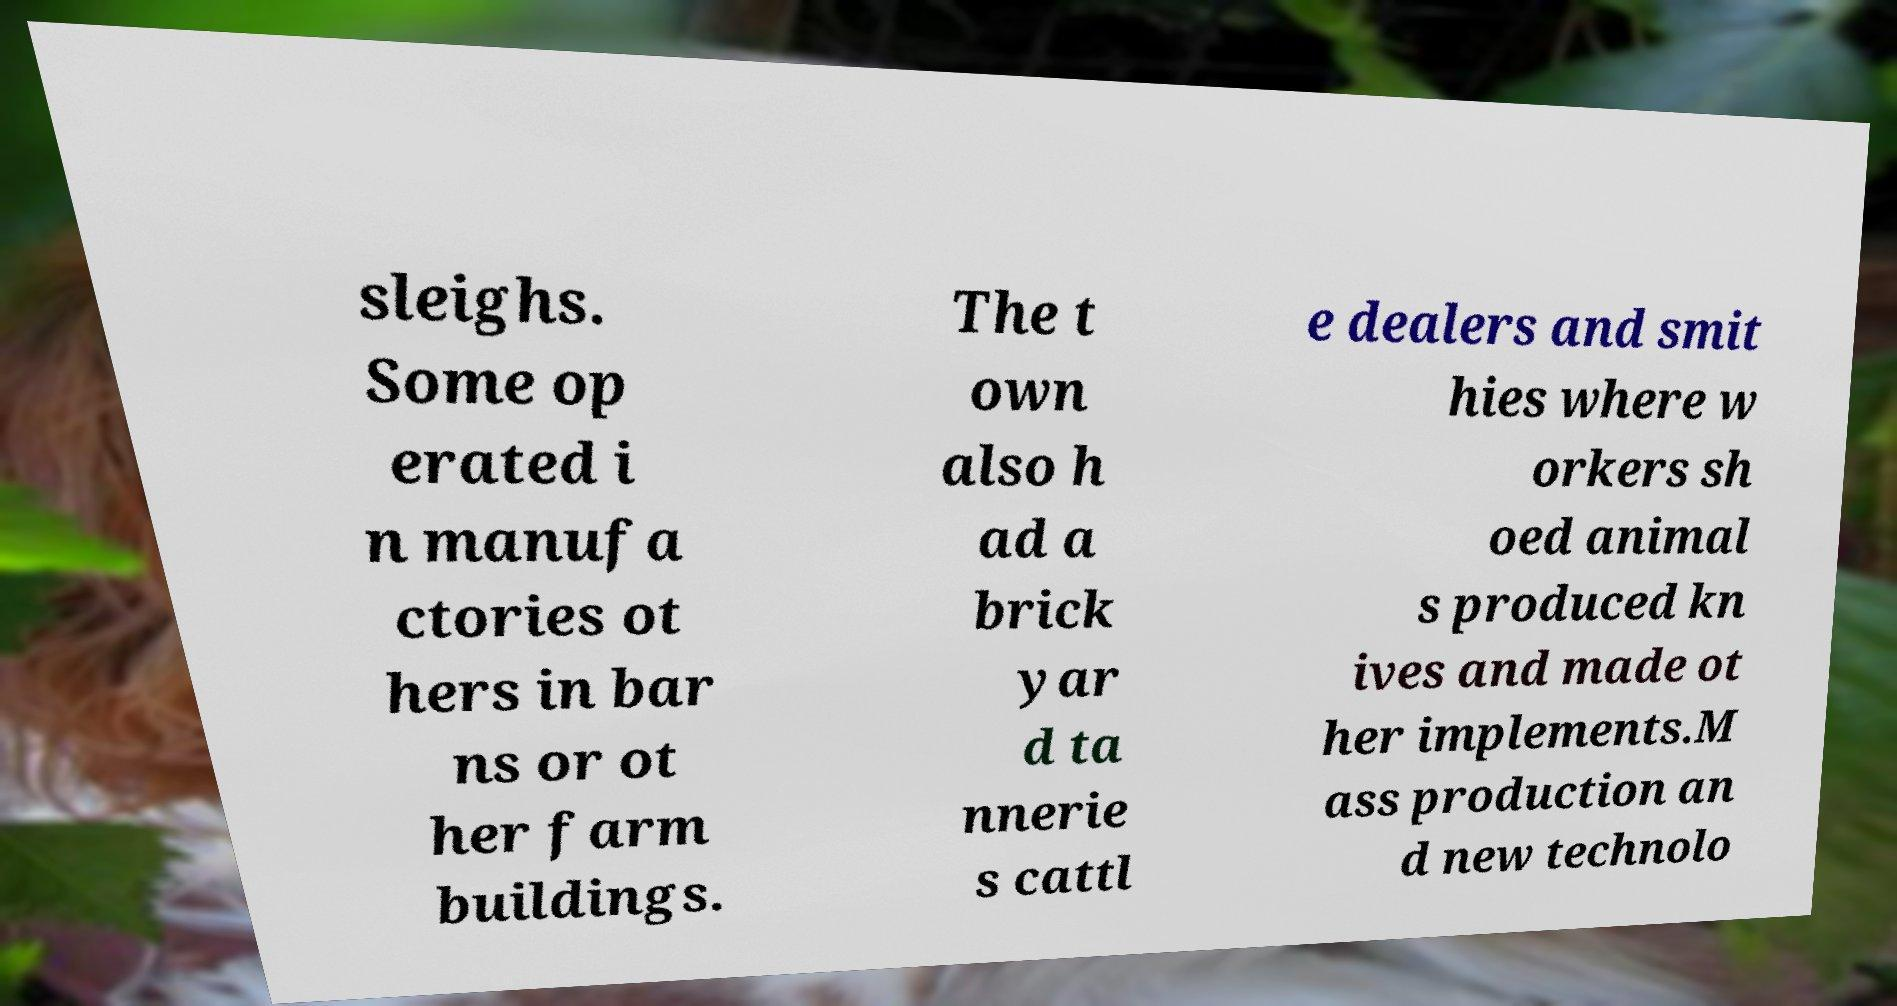Could you assist in decoding the text presented in this image and type it out clearly? sleighs. Some op erated i n manufa ctories ot hers in bar ns or ot her farm buildings. The t own also h ad a brick yar d ta nnerie s cattl e dealers and smit hies where w orkers sh oed animal s produced kn ives and made ot her implements.M ass production an d new technolo 